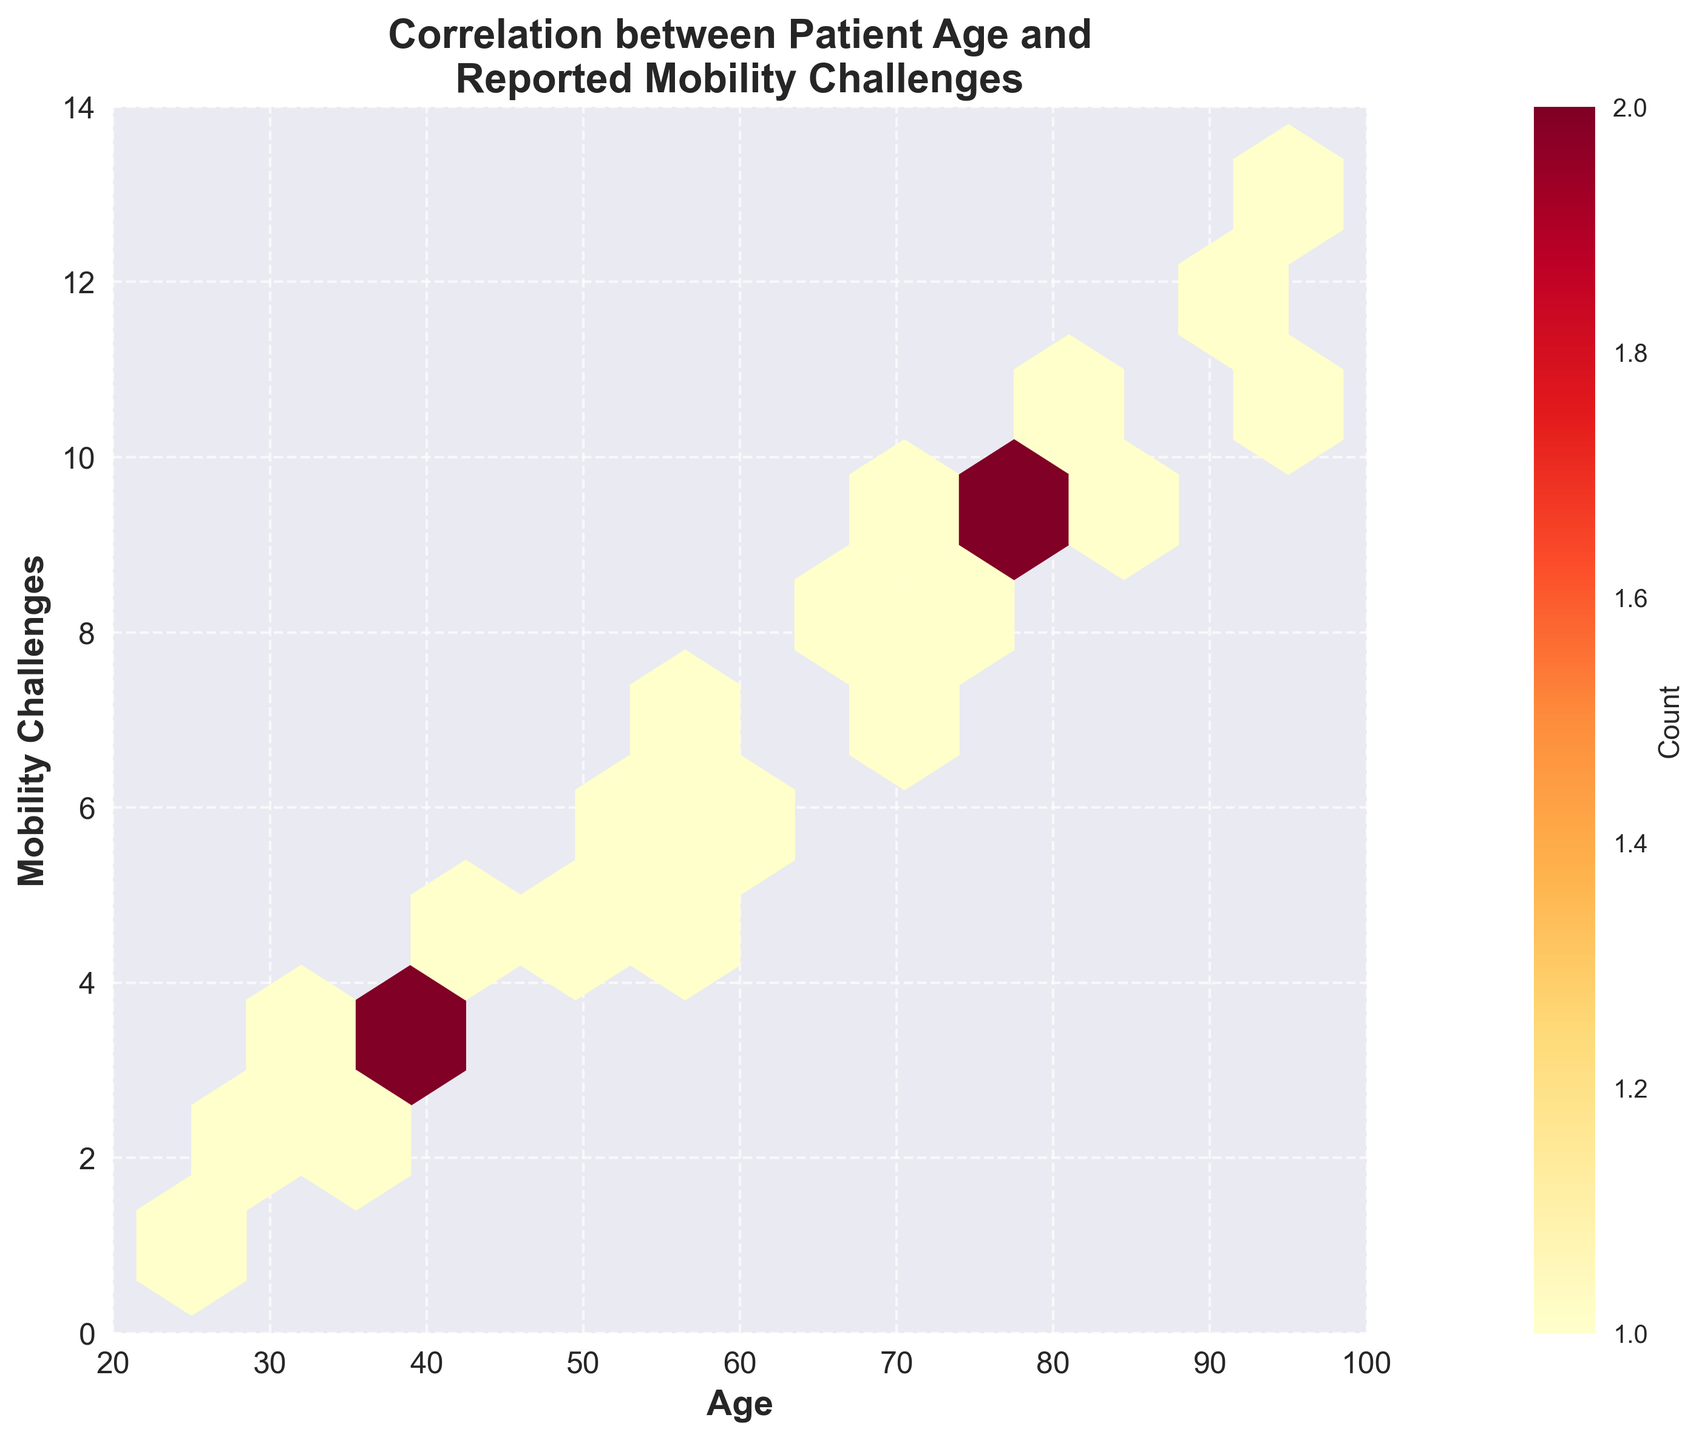How many age intervals are represented on the X-axis? The X-axis represents the age of patients, and from the figure, there are age intervals ranging from 20 to 100, with ticks at 20, 40, 60, 80, and 100. Each tick represents an interval.
Answer: 5 What is the main color gradient of the hexbin plot? The hexbin plot's color gradient is represented by shades of yellow, orange, and red, as shown on the legend bar labeled "Count."
Answer: Yellow to Red How does increasing age seem to affect reported mobility challenges? By observing the plot, there is a noticeable trend: as age increases, the number of reported mobility challenges also tends to increase, as indicated by higher values on the Y-axis at older ages.
Answer: Increases Where do you observe the highest density of data points? The color intensity is highest around the age range of 65 to 80 and mobility challenges between 7 and 10, as the red color in this area indicates a higher count density.
Answer: Ages 65-80 and challenges 7-10 What is the upper limit for the number of mobility challenges reported on the Y-axis? The Y-axis of the hexbin plot shows that the highest value for reported mobility challenges is 13.
Answer: 13 What does a darker red hexbin indicate compared to a lighter yellow one? In the color gradient used, darker red hexagons represent areas with a higher count of overlapping data points, indicating higher density, whereas lighter yellow hexagons represent areas with fewer data points.
Answer: Higher Density What can you infer about patients aged 25 to 40? Patients aged 25 to 40 mostly report lower mobility challenges, with values ranging roughly from 1 to 4, as observed in the lower-left portion of the plot with lighter colors.
Answer: Lower challenges (1-4) Which age group has the broadest range of reported mobility challenges and what is that range? By examining the spread in different age bins, the age group 80-100 reports a broad range of challenges from about 9 to 13, making it the broadest range.
Answer: 80-100; 9-13 For ages 60 to 80, what is the approximate range of reported mobility challenges? The hexbin plot shows that for ages 60 to 80, reported mobility challenges range approximately from 6 to 10, observed in the mid-section with a higher count density.
Answer: 6-10 